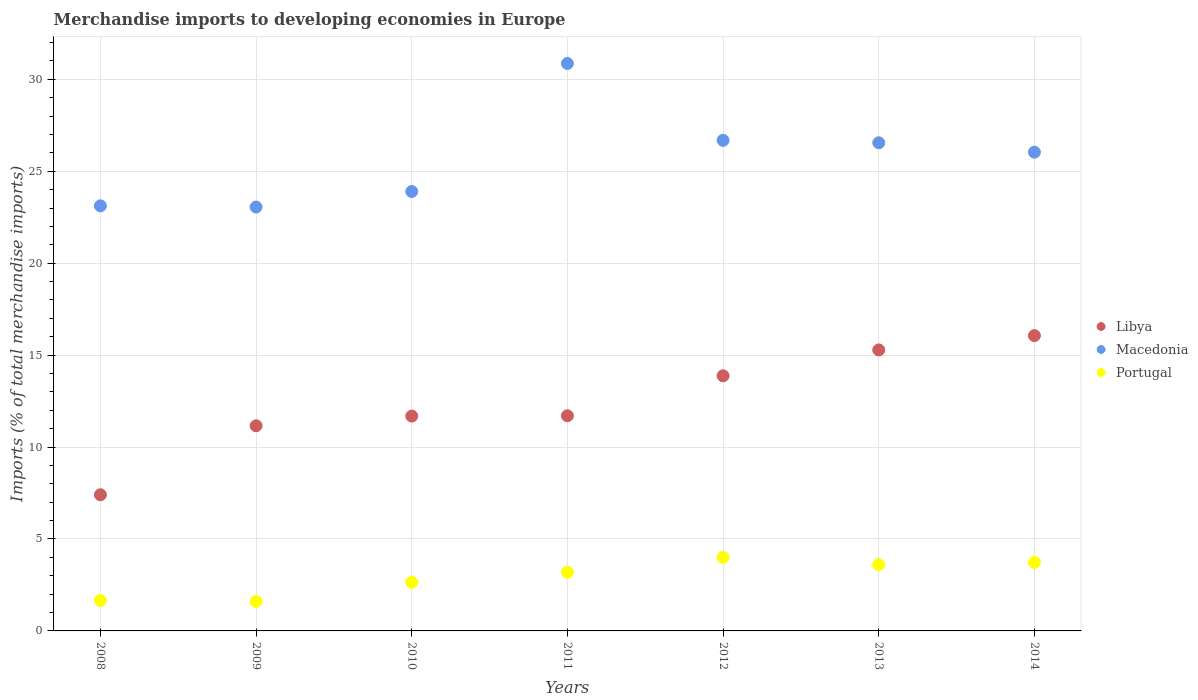How many different coloured dotlines are there?
Your answer should be compact. 3. What is the percentage total merchandise imports in Macedonia in 2010?
Give a very brief answer. 23.9. Across all years, what is the maximum percentage total merchandise imports in Portugal?
Your answer should be compact. 4. Across all years, what is the minimum percentage total merchandise imports in Libya?
Keep it short and to the point. 7.41. In which year was the percentage total merchandise imports in Portugal maximum?
Make the answer very short. 2012. In which year was the percentage total merchandise imports in Macedonia minimum?
Provide a succinct answer. 2009. What is the total percentage total merchandise imports in Libya in the graph?
Offer a terse response. 87.17. What is the difference between the percentage total merchandise imports in Libya in 2012 and that in 2013?
Keep it short and to the point. -1.41. What is the difference between the percentage total merchandise imports in Portugal in 2014 and the percentage total merchandise imports in Libya in 2009?
Make the answer very short. -7.43. What is the average percentage total merchandise imports in Libya per year?
Your answer should be compact. 12.45. In the year 2011, what is the difference between the percentage total merchandise imports in Libya and percentage total merchandise imports in Macedonia?
Provide a succinct answer. -19.16. In how many years, is the percentage total merchandise imports in Macedonia greater than 6 %?
Ensure brevity in your answer.  7. What is the ratio of the percentage total merchandise imports in Portugal in 2008 to that in 2014?
Your answer should be compact. 0.44. Is the percentage total merchandise imports in Macedonia in 2008 less than that in 2012?
Keep it short and to the point. Yes. What is the difference between the highest and the second highest percentage total merchandise imports in Libya?
Offer a very short reply. 0.78. What is the difference between the highest and the lowest percentage total merchandise imports in Macedonia?
Your response must be concise. 7.81. Is the percentage total merchandise imports in Libya strictly greater than the percentage total merchandise imports in Portugal over the years?
Give a very brief answer. Yes. Is the percentage total merchandise imports in Macedonia strictly less than the percentage total merchandise imports in Libya over the years?
Give a very brief answer. No. What is the difference between two consecutive major ticks on the Y-axis?
Keep it short and to the point. 5. Are the values on the major ticks of Y-axis written in scientific E-notation?
Provide a short and direct response. No. Does the graph contain any zero values?
Your answer should be compact. No. How many legend labels are there?
Your answer should be very brief. 3. How are the legend labels stacked?
Your answer should be compact. Vertical. What is the title of the graph?
Your answer should be very brief. Merchandise imports to developing economies in Europe. What is the label or title of the Y-axis?
Keep it short and to the point. Imports (% of total merchandise imports). What is the Imports (% of total merchandise imports) of Libya in 2008?
Offer a terse response. 7.41. What is the Imports (% of total merchandise imports) in Macedonia in 2008?
Give a very brief answer. 23.12. What is the Imports (% of total merchandise imports) of Portugal in 2008?
Your response must be concise. 1.66. What is the Imports (% of total merchandise imports) in Libya in 2009?
Offer a terse response. 11.16. What is the Imports (% of total merchandise imports) in Macedonia in 2009?
Your answer should be very brief. 23.06. What is the Imports (% of total merchandise imports) in Portugal in 2009?
Your response must be concise. 1.6. What is the Imports (% of total merchandise imports) of Libya in 2010?
Give a very brief answer. 11.69. What is the Imports (% of total merchandise imports) of Macedonia in 2010?
Keep it short and to the point. 23.9. What is the Imports (% of total merchandise imports) in Portugal in 2010?
Give a very brief answer. 2.65. What is the Imports (% of total merchandise imports) of Libya in 2011?
Make the answer very short. 11.7. What is the Imports (% of total merchandise imports) of Macedonia in 2011?
Provide a succinct answer. 30.87. What is the Imports (% of total merchandise imports) in Portugal in 2011?
Your response must be concise. 3.19. What is the Imports (% of total merchandise imports) of Libya in 2012?
Give a very brief answer. 13.88. What is the Imports (% of total merchandise imports) of Macedonia in 2012?
Offer a very short reply. 26.68. What is the Imports (% of total merchandise imports) in Portugal in 2012?
Provide a short and direct response. 4. What is the Imports (% of total merchandise imports) of Libya in 2013?
Your answer should be very brief. 15.28. What is the Imports (% of total merchandise imports) in Macedonia in 2013?
Your answer should be compact. 26.55. What is the Imports (% of total merchandise imports) of Portugal in 2013?
Provide a short and direct response. 3.6. What is the Imports (% of total merchandise imports) of Libya in 2014?
Offer a terse response. 16.06. What is the Imports (% of total merchandise imports) in Macedonia in 2014?
Keep it short and to the point. 26.04. What is the Imports (% of total merchandise imports) of Portugal in 2014?
Your answer should be compact. 3.73. Across all years, what is the maximum Imports (% of total merchandise imports) of Libya?
Your response must be concise. 16.06. Across all years, what is the maximum Imports (% of total merchandise imports) in Macedonia?
Keep it short and to the point. 30.87. Across all years, what is the maximum Imports (% of total merchandise imports) of Portugal?
Offer a terse response. 4. Across all years, what is the minimum Imports (% of total merchandise imports) in Libya?
Your answer should be very brief. 7.41. Across all years, what is the minimum Imports (% of total merchandise imports) of Macedonia?
Your response must be concise. 23.06. Across all years, what is the minimum Imports (% of total merchandise imports) of Portugal?
Ensure brevity in your answer.  1.6. What is the total Imports (% of total merchandise imports) in Libya in the graph?
Make the answer very short. 87.17. What is the total Imports (% of total merchandise imports) of Macedonia in the graph?
Give a very brief answer. 180.22. What is the total Imports (% of total merchandise imports) of Portugal in the graph?
Keep it short and to the point. 20.43. What is the difference between the Imports (% of total merchandise imports) in Libya in 2008 and that in 2009?
Provide a succinct answer. -3.75. What is the difference between the Imports (% of total merchandise imports) of Macedonia in 2008 and that in 2009?
Ensure brevity in your answer.  0.07. What is the difference between the Imports (% of total merchandise imports) in Portugal in 2008 and that in 2009?
Ensure brevity in your answer.  0.05. What is the difference between the Imports (% of total merchandise imports) in Libya in 2008 and that in 2010?
Provide a succinct answer. -4.28. What is the difference between the Imports (% of total merchandise imports) of Macedonia in 2008 and that in 2010?
Give a very brief answer. -0.78. What is the difference between the Imports (% of total merchandise imports) in Portugal in 2008 and that in 2010?
Keep it short and to the point. -0.99. What is the difference between the Imports (% of total merchandise imports) of Libya in 2008 and that in 2011?
Your answer should be very brief. -4.3. What is the difference between the Imports (% of total merchandise imports) of Macedonia in 2008 and that in 2011?
Your answer should be compact. -7.74. What is the difference between the Imports (% of total merchandise imports) of Portugal in 2008 and that in 2011?
Provide a succinct answer. -1.53. What is the difference between the Imports (% of total merchandise imports) of Libya in 2008 and that in 2012?
Ensure brevity in your answer.  -6.47. What is the difference between the Imports (% of total merchandise imports) of Macedonia in 2008 and that in 2012?
Ensure brevity in your answer.  -3.56. What is the difference between the Imports (% of total merchandise imports) in Portugal in 2008 and that in 2012?
Your answer should be very brief. -2.35. What is the difference between the Imports (% of total merchandise imports) in Libya in 2008 and that in 2013?
Make the answer very short. -7.88. What is the difference between the Imports (% of total merchandise imports) of Macedonia in 2008 and that in 2013?
Provide a short and direct response. -3.43. What is the difference between the Imports (% of total merchandise imports) of Portugal in 2008 and that in 2013?
Ensure brevity in your answer.  -1.95. What is the difference between the Imports (% of total merchandise imports) of Libya in 2008 and that in 2014?
Provide a short and direct response. -8.66. What is the difference between the Imports (% of total merchandise imports) of Macedonia in 2008 and that in 2014?
Make the answer very short. -2.92. What is the difference between the Imports (% of total merchandise imports) in Portugal in 2008 and that in 2014?
Provide a succinct answer. -2.07. What is the difference between the Imports (% of total merchandise imports) of Libya in 2009 and that in 2010?
Offer a terse response. -0.53. What is the difference between the Imports (% of total merchandise imports) in Macedonia in 2009 and that in 2010?
Make the answer very short. -0.85. What is the difference between the Imports (% of total merchandise imports) in Portugal in 2009 and that in 2010?
Your answer should be compact. -1.04. What is the difference between the Imports (% of total merchandise imports) of Libya in 2009 and that in 2011?
Ensure brevity in your answer.  -0.55. What is the difference between the Imports (% of total merchandise imports) in Macedonia in 2009 and that in 2011?
Make the answer very short. -7.81. What is the difference between the Imports (% of total merchandise imports) of Portugal in 2009 and that in 2011?
Your answer should be very brief. -1.59. What is the difference between the Imports (% of total merchandise imports) of Libya in 2009 and that in 2012?
Provide a succinct answer. -2.72. What is the difference between the Imports (% of total merchandise imports) of Macedonia in 2009 and that in 2012?
Your answer should be very brief. -3.63. What is the difference between the Imports (% of total merchandise imports) in Portugal in 2009 and that in 2012?
Offer a very short reply. -2.4. What is the difference between the Imports (% of total merchandise imports) of Libya in 2009 and that in 2013?
Offer a terse response. -4.13. What is the difference between the Imports (% of total merchandise imports) of Macedonia in 2009 and that in 2013?
Keep it short and to the point. -3.5. What is the difference between the Imports (% of total merchandise imports) in Libya in 2009 and that in 2014?
Your response must be concise. -4.91. What is the difference between the Imports (% of total merchandise imports) in Macedonia in 2009 and that in 2014?
Make the answer very short. -2.99. What is the difference between the Imports (% of total merchandise imports) in Portugal in 2009 and that in 2014?
Provide a short and direct response. -2.12. What is the difference between the Imports (% of total merchandise imports) of Libya in 2010 and that in 2011?
Make the answer very short. -0.02. What is the difference between the Imports (% of total merchandise imports) of Macedonia in 2010 and that in 2011?
Ensure brevity in your answer.  -6.96. What is the difference between the Imports (% of total merchandise imports) in Portugal in 2010 and that in 2011?
Keep it short and to the point. -0.54. What is the difference between the Imports (% of total merchandise imports) in Libya in 2010 and that in 2012?
Give a very brief answer. -2.19. What is the difference between the Imports (% of total merchandise imports) in Macedonia in 2010 and that in 2012?
Your response must be concise. -2.78. What is the difference between the Imports (% of total merchandise imports) of Portugal in 2010 and that in 2012?
Make the answer very short. -1.36. What is the difference between the Imports (% of total merchandise imports) of Libya in 2010 and that in 2013?
Your answer should be very brief. -3.6. What is the difference between the Imports (% of total merchandise imports) in Macedonia in 2010 and that in 2013?
Make the answer very short. -2.65. What is the difference between the Imports (% of total merchandise imports) in Portugal in 2010 and that in 2013?
Offer a terse response. -0.96. What is the difference between the Imports (% of total merchandise imports) in Libya in 2010 and that in 2014?
Ensure brevity in your answer.  -4.38. What is the difference between the Imports (% of total merchandise imports) in Macedonia in 2010 and that in 2014?
Offer a very short reply. -2.14. What is the difference between the Imports (% of total merchandise imports) of Portugal in 2010 and that in 2014?
Offer a very short reply. -1.08. What is the difference between the Imports (% of total merchandise imports) in Libya in 2011 and that in 2012?
Provide a succinct answer. -2.17. What is the difference between the Imports (% of total merchandise imports) of Macedonia in 2011 and that in 2012?
Offer a terse response. 4.18. What is the difference between the Imports (% of total merchandise imports) of Portugal in 2011 and that in 2012?
Ensure brevity in your answer.  -0.81. What is the difference between the Imports (% of total merchandise imports) of Libya in 2011 and that in 2013?
Offer a very short reply. -3.58. What is the difference between the Imports (% of total merchandise imports) of Macedonia in 2011 and that in 2013?
Offer a very short reply. 4.31. What is the difference between the Imports (% of total merchandise imports) in Portugal in 2011 and that in 2013?
Make the answer very short. -0.41. What is the difference between the Imports (% of total merchandise imports) in Libya in 2011 and that in 2014?
Offer a very short reply. -4.36. What is the difference between the Imports (% of total merchandise imports) in Macedonia in 2011 and that in 2014?
Ensure brevity in your answer.  4.82. What is the difference between the Imports (% of total merchandise imports) in Portugal in 2011 and that in 2014?
Provide a succinct answer. -0.54. What is the difference between the Imports (% of total merchandise imports) of Libya in 2012 and that in 2013?
Make the answer very short. -1.41. What is the difference between the Imports (% of total merchandise imports) of Macedonia in 2012 and that in 2013?
Your answer should be compact. 0.13. What is the difference between the Imports (% of total merchandise imports) in Portugal in 2012 and that in 2013?
Make the answer very short. 0.4. What is the difference between the Imports (% of total merchandise imports) of Libya in 2012 and that in 2014?
Provide a short and direct response. -2.19. What is the difference between the Imports (% of total merchandise imports) of Macedonia in 2012 and that in 2014?
Make the answer very short. 0.64. What is the difference between the Imports (% of total merchandise imports) in Portugal in 2012 and that in 2014?
Provide a succinct answer. 0.28. What is the difference between the Imports (% of total merchandise imports) of Libya in 2013 and that in 2014?
Offer a very short reply. -0.78. What is the difference between the Imports (% of total merchandise imports) of Macedonia in 2013 and that in 2014?
Provide a succinct answer. 0.51. What is the difference between the Imports (% of total merchandise imports) of Portugal in 2013 and that in 2014?
Your answer should be very brief. -0.12. What is the difference between the Imports (% of total merchandise imports) of Libya in 2008 and the Imports (% of total merchandise imports) of Macedonia in 2009?
Your response must be concise. -15.65. What is the difference between the Imports (% of total merchandise imports) in Libya in 2008 and the Imports (% of total merchandise imports) in Portugal in 2009?
Give a very brief answer. 5.8. What is the difference between the Imports (% of total merchandise imports) of Macedonia in 2008 and the Imports (% of total merchandise imports) of Portugal in 2009?
Keep it short and to the point. 21.52. What is the difference between the Imports (% of total merchandise imports) of Libya in 2008 and the Imports (% of total merchandise imports) of Macedonia in 2010?
Make the answer very short. -16.5. What is the difference between the Imports (% of total merchandise imports) in Libya in 2008 and the Imports (% of total merchandise imports) in Portugal in 2010?
Your answer should be very brief. 4.76. What is the difference between the Imports (% of total merchandise imports) in Macedonia in 2008 and the Imports (% of total merchandise imports) in Portugal in 2010?
Keep it short and to the point. 20.47. What is the difference between the Imports (% of total merchandise imports) of Libya in 2008 and the Imports (% of total merchandise imports) of Macedonia in 2011?
Give a very brief answer. -23.46. What is the difference between the Imports (% of total merchandise imports) in Libya in 2008 and the Imports (% of total merchandise imports) in Portugal in 2011?
Make the answer very short. 4.22. What is the difference between the Imports (% of total merchandise imports) in Macedonia in 2008 and the Imports (% of total merchandise imports) in Portugal in 2011?
Keep it short and to the point. 19.93. What is the difference between the Imports (% of total merchandise imports) in Libya in 2008 and the Imports (% of total merchandise imports) in Macedonia in 2012?
Make the answer very short. -19.28. What is the difference between the Imports (% of total merchandise imports) of Libya in 2008 and the Imports (% of total merchandise imports) of Portugal in 2012?
Make the answer very short. 3.4. What is the difference between the Imports (% of total merchandise imports) in Macedonia in 2008 and the Imports (% of total merchandise imports) in Portugal in 2012?
Offer a terse response. 19.12. What is the difference between the Imports (% of total merchandise imports) of Libya in 2008 and the Imports (% of total merchandise imports) of Macedonia in 2013?
Provide a succinct answer. -19.15. What is the difference between the Imports (% of total merchandise imports) in Libya in 2008 and the Imports (% of total merchandise imports) in Portugal in 2013?
Offer a terse response. 3.8. What is the difference between the Imports (% of total merchandise imports) of Macedonia in 2008 and the Imports (% of total merchandise imports) of Portugal in 2013?
Offer a very short reply. 19.52. What is the difference between the Imports (% of total merchandise imports) of Libya in 2008 and the Imports (% of total merchandise imports) of Macedonia in 2014?
Your answer should be compact. -18.64. What is the difference between the Imports (% of total merchandise imports) of Libya in 2008 and the Imports (% of total merchandise imports) of Portugal in 2014?
Offer a very short reply. 3.68. What is the difference between the Imports (% of total merchandise imports) of Macedonia in 2008 and the Imports (% of total merchandise imports) of Portugal in 2014?
Ensure brevity in your answer.  19.4. What is the difference between the Imports (% of total merchandise imports) of Libya in 2009 and the Imports (% of total merchandise imports) of Macedonia in 2010?
Keep it short and to the point. -12.75. What is the difference between the Imports (% of total merchandise imports) in Libya in 2009 and the Imports (% of total merchandise imports) in Portugal in 2010?
Your response must be concise. 8.51. What is the difference between the Imports (% of total merchandise imports) of Macedonia in 2009 and the Imports (% of total merchandise imports) of Portugal in 2010?
Provide a succinct answer. 20.41. What is the difference between the Imports (% of total merchandise imports) in Libya in 2009 and the Imports (% of total merchandise imports) in Macedonia in 2011?
Ensure brevity in your answer.  -19.71. What is the difference between the Imports (% of total merchandise imports) in Libya in 2009 and the Imports (% of total merchandise imports) in Portugal in 2011?
Offer a very short reply. 7.97. What is the difference between the Imports (% of total merchandise imports) in Macedonia in 2009 and the Imports (% of total merchandise imports) in Portugal in 2011?
Ensure brevity in your answer.  19.87. What is the difference between the Imports (% of total merchandise imports) of Libya in 2009 and the Imports (% of total merchandise imports) of Macedonia in 2012?
Offer a very short reply. -15.53. What is the difference between the Imports (% of total merchandise imports) of Libya in 2009 and the Imports (% of total merchandise imports) of Portugal in 2012?
Your answer should be compact. 7.15. What is the difference between the Imports (% of total merchandise imports) in Macedonia in 2009 and the Imports (% of total merchandise imports) in Portugal in 2012?
Provide a short and direct response. 19.05. What is the difference between the Imports (% of total merchandise imports) of Libya in 2009 and the Imports (% of total merchandise imports) of Macedonia in 2013?
Offer a terse response. -15.4. What is the difference between the Imports (% of total merchandise imports) of Libya in 2009 and the Imports (% of total merchandise imports) of Portugal in 2013?
Offer a very short reply. 7.55. What is the difference between the Imports (% of total merchandise imports) in Macedonia in 2009 and the Imports (% of total merchandise imports) in Portugal in 2013?
Make the answer very short. 19.45. What is the difference between the Imports (% of total merchandise imports) of Libya in 2009 and the Imports (% of total merchandise imports) of Macedonia in 2014?
Your answer should be very brief. -14.88. What is the difference between the Imports (% of total merchandise imports) in Libya in 2009 and the Imports (% of total merchandise imports) in Portugal in 2014?
Offer a very short reply. 7.43. What is the difference between the Imports (% of total merchandise imports) of Macedonia in 2009 and the Imports (% of total merchandise imports) of Portugal in 2014?
Provide a succinct answer. 19.33. What is the difference between the Imports (% of total merchandise imports) in Libya in 2010 and the Imports (% of total merchandise imports) in Macedonia in 2011?
Your answer should be very brief. -19.18. What is the difference between the Imports (% of total merchandise imports) of Libya in 2010 and the Imports (% of total merchandise imports) of Portugal in 2011?
Your response must be concise. 8.5. What is the difference between the Imports (% of total merchandise imports) of Macedonia in 2010 and the Imports (% of total merchandise imports) of Portugal in 2011?
Your answer should be very brief. 20.71. What is the difference between the Imports (% of total merchandise imports) of Libya in 2010 and the Imports (% of total merchandise imports) of Macedonia in 2012?
Give a very brief answer. -15. What is the difference between the Imports (% of total merchandise imports) of Libya in 2010 and the Imports (% of total merchandise imports) of Portugal in 2012?
Ensure brevity in your answer.  7.68. What is the difference between the Imports (% of total merchandise imports) of Macedonia in 2010 and the Imports (% of total merchandise imports) of Portugal in 2012?
Your answer should be very brief. 19.9. What is the difference between the Imports (% of total merchandise imports) in Libya in 2010 and the Imports (% of total merchandise imports) in Macedonia in 2013?
Provide a short and direct response. -14.87. What is the difference between the Imports (% of total merchandise imports) of Libya in 2010 and the Imports (% of total merchandise imports) of Portugal in 2013?
Keep it short and to the point. 8.08. What is the difference between the Imports (% of total merchandise imports) of Macedonia in 2010 and the Imports (% of total merchandise imports) of Portugal in 2013?
Keep it short and to the point. 20.3. What is the difference between the Imports (% of total merchandise imports) of Libya in 2010 and the Imports (% of total merchandise imports) of Macedonia in 2014?
Provide a short and direct response. -14.36. What is the difference between the Imports (% of total merchandise imports) of Libya in 2010 and the Imports (% of total merchandise imports) of Portugal in 2014?
Provide a succinct answer. 7.96. What is the difference between the Imports (% of total merchandise imports) of Macedonia in 2010 and the Imports (% of total merchandise imports) of Portugal in 2014?
Ensure brevity in your answer.  20.18. What is the difference between the Imports (% of total merchandise imports) of Libya in 2011 and the Imports (% of total merchandise imports) of Macedonia in 2012?
Your answer should be very brief. -14.98. What is the difference between the Imports (% of total merchandise imports) in Libya in 2011 and the Imports (% of total merchandise imports) in Portugal in 2012?
Your answer should be compact. 7.7. What is the difference between the Imports (% of total merchandise imports) in Macedonia in 2011 and the Imports (% of total merchandise imports) in Portugal in 2012?
Give a very brief answer. 26.86. What is the difference between the Imports (% of total merchandise imports) of Libya in 2011 and the Imports (% of total merchandise imports) of Macedonia in 2013?
Give a very brief answer. -14.85. What is the difference between the Imports (% of total merchandise imports) of Libya in 2011 and the Imports (% of total merchandise imports) of Portugal in 2013?
Provide a short and direct response. 8.1. What is the difference between the Imports (% of total merchandise imports) of Macedonia in 2011 and the Imports (% of total merchandise imports) of Portugal in 2013?
Ensure brevity in your answer.  27.26. What is the difference between the Imports (% of total merchandise imports) in Libya in 2011 and the Imports (% of total merchandise imports) in Macedonia in 2014?
Your answer should be very brief. -14.34. What is the difference between the Imports (% of total merchandise imports) of Libya in 2011 and the Imports (% of total merchandise imports) of Portugal in 2014?
Provide a succinct answer. 7.98. What is the difference between the Imports (% of total merchandise imports) in Macedonia in 2011 and the Imports (% of total merchandise imports) in Portugal in 2014?
Provide a short and direct response. 27.14. What is the difference between the Imports (% of total merchandise imports) in Libya in 2012 and the Imports (% of total merchandise imports) in Macedonia in 2013?
Offer a terse response. -12.68. What is the difference between the Imports (% of total merchandise imports) in Libya in 2012 and the Imports (% of total merchandise imports) in Portugal in 2013?
Make the answer very short. 10.27. What is the difference between the Imports (% of total merchandise imports) in Macedonia in 2012 and the Imports (% of total merchandise imports) in Portugal in 2013?
Give a very brief answer. 23.08. What is the difference between the Imports (% of total merchandise imports) of Libya in 2012 and the Imports (% of total merchandise imports) of Macedonia in 2014?
Ensure brevity in your answer.  -12.16. What is the difference between the Imports (% of total merchandise imports) in Libya in 2012 and the Imports (% of total merchandise imports) in Portugal in 2014?
Provide a succinct answer. 10.15. What is the difference between the Imports (% of total merchandise imports) of Macedonia in 2012 and the Imports (% of total merchandise imports) of Portugal in 2014?
Make the answer very short. 22.96. What is the difference between the Imports (% of total merchandise imports) of Libya in 2013 and the Imports (% of total merchandise imports) of Macedonia in 2014?
Your answer should be compact. -10.76. What is the difference between the Imports (% of total merchandise imports) of Libya in 2013 and the Imports (% of total merchandise imports) of Portugal in 2014?
Provide a short and direct response. 11.56. What is the difference between the Imports (% of total merchandise imports) of Macedonia in 2013 and the Imports (% of total merchandise imports) of Portugal in 2014?
Give a very brief answer. 22.83. What is the average Imports (% of total merchandise imports) of Libya per year?
Provide a succinct answer. 12.45. What is the average Imports (% of total merchandise imports) in Macedonia per year?
Give a very brief answer. 25.75. What is the average Imports (% of total merchandise imports) in Portugal per year?
Your answer should be very brief. 2.92. In the year 2008, what is the difference between the Imports (% of total merchandise imports) in Libya and Imports (% of total merchandise imports) in Macedonia?
Provide a short and direct response. -15.72. In the year 2008, what is the difference between the Imports (% of total merchandise imports) of Libya and Imports (% of total merchandise imports) of Portugal?
Your response must be concise. 5.75. In the year 2008, what is the difference between the Imports (% of total merchandise imports) of Macedonia and Imports (% of total merchandise imports) of Portugal?
Ensure brevity in your answer.  21.47. In the year 2009, what is the difference between the Imports (% of total merchandise imports) in Libya and Imports (% of total merchandise imports) in Macedonia?
Your response must be concise. -11.9. In the year 2009, what is the difference between the Imports (% of total merchandise imports) in Libya and Imports (% of total merchandise imports) in Portugal?
Keep it short and to the point. 9.55. In the year 2009, what is the difference between the Imports (% of total merchandise imports) in Macedonia and Imports (% of total merchandise imports) in Portugal?
Offer a very short reply. 21.45. In the year 2010, what is the difference between the Imports (% of total merchandise imports) in Libya and Imports (% of total merchandise imports) in Macedonia?
Offer a very short reply. -12.22. In the year 2010, what is the difference between the Imports (% of total merchandise imports) of Libya and Imports (% of total merchandise imports) of Portugal?
Provide a succinct answer. 9.04. In the year 2010, what is the difference between the Imports (% of total merchandise imports) in Macedonia and Imports (% of total merchandise imports) in Portugal?
Ensure brevity in your answer.  21.25. In the year 2011, what is the difference between the Imports (% of total merchandise imports) in Libya and Imports (% of total merchandise imports) in Macedonia?
Offer a very short reply. -19.16. In the year 2011, what is the difference between the Imports (% of total merchandise imports) of Libya and Imports (% of total merchandise imports) of Portugal?
Your response must be concise. 8.51. In the year 2011, what is the difference between the Imports (% of total merchandise imports) in Macedonia and Imports (% of total merchandise imports) in Portugal?
Give a very brief answer. 27.68. In the year 2012, what is the difference between the Imports (% of total merchandise imports) of Libya and Imports (% of total merchandise imports) of Macedonia?
Offer a very short reply. -12.81. In the year 2012, what is the difference between the Imports (% of total merchandise imports) of Libya and Imports (% of total merchandise imports) of Portugal?
Your response must be concise. 9.87. In the year 2012, what is the difference between the Imports (% of total merchandise imports) in Macedonia and Imports (% of total merchandise imports) in Portugal?
Offer a very short reply. 22.68. In the year 2013, what is the difference between the Imports (% of total merchandise imports) of Libya and Imports (% of total merchandise imports) of Macedonia?
Your response must be concise. -11.27. In the year 2013, what is the difference between the Imports (% of total merchandise imports) in Libya and Imports (% of total merchandise imports) in Portugal?
Offer a terse response. 11.68. In the year 2013, what is the difference between the Imports (% of total merchandise imports) of Macedonia and Imports (% of total merchandise imports) of Portugal?
Your answer should be compact. 22.95. In the year 2014, what is the difference between the Imports (% of total merchandise imports) of Libya and Imports (% of total merchandise imports) of Macedonia?
Offer a terse response. -9.98. In the year 2014, what is the difference between the Imports (% of total merchandise imports) in Libya and Imports (% of total merchandise imports) in Portugal?
Offer a terse response. 12.34. In the year 2014, what is the difference between the Imports (% of total merchandise imports) in Macedonia and Imports (% of total merchandise imports) in Portugal?
Your response must be concise. 22.32. What is the ratio of the Imports (% of total merchandise imports) in Libya in 2008 to that in 2009?
Your response must be concise. 0.66. What is the ratio of the Imports (% of total merchandise imports) of Portugal in 2008 to that in 2009?
Make the answer very short. 1.03. What is the ratio of the Imports (% of total merchandise imports) of Libya in 2008 to that in 2010?
Give a very brief answer. 0.63. What is the ratio of the Imports (% of total merchandise imports) in Macedonia in 2008 to that in 2010?
Provide a succinct answer. 0.97. What is the ratio of the Imports (% of total merchandise imports) of Portugal in 2008 to that in 2010?
Give a very brief answer. 0.63. What is the ratio of the Imports (% of total merchandise imports) of Libya in 2008 to that in 2011?
Provide a short and direct response. 0.63. What is the ratio of the Imports (% of total merchandise imports) in Macedonia in 2008 to that in 2011?
Your answer should be very brief. 0.75. What is the ratio of the Imports (% of total merchandise imports) of Portugal in 2008 to that in 2011?
Your answer should be compact. 0.52. What is the ratio of the Imports (% of total merchandise imports) of Libya in 2008 to that in 2012?
Ensure brevity in your answer.  0.53. What is the ratio of the Imports (% of total merchandise imports) of Macedonia in 2008 to that in 2012?
Give a very brief answer. 0.87. What is the ratio of the Imports (% of total merchandise imports) of Portugal in 2008 to that in 2012?
Provide a succinct answer. 0.41. What is the ratio of the Imports (% of total merchandise imports) in Libya in 2008 to that in 2013?
Ensure brevity in your answer.  0.48. What is the ratio of the Imports (% of total merchandise imports) in Macedonia in 2008 to that in 2013?
Your response must be concise. 0.87. What is the ratio of the Imports (% of total merchandise imports) in Portugal in 2008 to that in 2013?
Offer a very short reply. 0.46. What is the ratio of the Imports (% of total merchandise imports) in Libya in 2008 to that in 2014?
Give a very brief answer. 0.46. What is the ratio of the Imports (% of total merchandise imports) of Macedonia in 2008 to that in 2014?
Keep it short and to the point. 0.89. What is the ratio of the Imports (% of total merchandise imports) of Portugal in 2008 to that in 2014?
Keep it short and to the point. 0.44. What is the ratio of the Imports (% of total merchandise imports) of Libya in 2009 to that in 2010?
Your response must be concise. 0.95. What is the ratio of the Imports (% of total merchandise imports) in Macedonia in 2009 to that in 2010?
Your response must be concise. 0.96. What is the ratio of the Imports (% of total merchandise imports) in Portugal in 2009 to that in 2010?
Keep it short and to the point. 0.61. What is the ratio of the Imports (% of total merchandise imports) in Libya in 2009 to that in 2011?
Your answer should be compact. 0.95. What is the ratio of the Imports (% of total merchandise imports) of Macedonia in 2009 to that in 2011?
Offer a very short reply. 0.75. What is the ratio of the Imports (% of total merchandise imports) in Portugal in 2009 to that in 2011?
Ensure brevity in your answer.  0.5. What is the ratio of the Imports (% of total merchandise imports) in Libya in 2009 to that in 2012?
Your response must be concise. 0.8. What is the ratio of the Imports (% of total merchandise imports) of Macedonia in 2009 to that in 2012?
Your answer should be compact. 0.86. What is the ratio of the Imports (% of total merchandise imports) in Portugal in 2009 to that in 2012?
Provide a short and direct response. 0.4. What is the ratio of the Imports (% of total merchandise imports) of Libya in 2009 to that in 2013?
Make the answer very short. 0.73. What is the ratio of the Imports (% of total merchandise imports) of Macedonia in 2009 to that in 2013?
Your answer should be very brief. 0.87. What is the ratio of the Imports (% of total merchandise imports) of Portugal in 2009 to that in 2013?
Offer a terse response. 0.44. What is the ratio of the Imports (% of total merchandise imports) of Libya in 2009 to that in 2014?
Keep it short and to the point. 0.69. What is the ratio of the Imports (% of total merchandise imports) in Macedonia in 2009 to that in 2014?
Your answer should be compact. 0.89. What is the ratio of the Imports (% of total merchandise imports) in Portugal in 2009 to that in 2014?
Give a very brief answer. 0.43. What is the ratio of the Imports (% of total merchandise imports) of Macedonia in 2010 to that in 2011?
Give a very brief answer. 0.77. What is the ratio of the Imports (% of total merchandise imports) in Portugal in 2010 to that in 2011?
Provide a short and direct response. 0.83. What is the ratio of the Imports (% of total merchandise imports) in Libya in 2010 to that in 2012?
Your answer should be very brief. 0.84. What is the ratio of the Imports (% of total merchandise imports) of Macedonia in 2010 to that in 2012?
Keep it short and to the point. 0.9. What is the ratio of the Imports (% of total merchandise imports) of Portugal in 2010 to that in 2012?
Your answer should be compact. 0.66. What is the ratio of the Imports (% of total merchandise imports) of Libya in 2010 to that in 2013?
Offer a terse response. 0.76. What is the ratio of the Imports (% of total merchandise imports) in Macedonia in 2010 to that in 2013?
Ensure brevity in your answer.  0.9. What is the ratio of the Imports (% of total merchandise imports) of Portugal in 2010 to that in 2013?
Your answer should be very brief. 0.73. What is the ratio of the Imports (% of total merchandise imports) in Libya in 2010 to that in 2014?
Provide a short and direct response. 0.73. What is the ratio of the Imports (% of total merchandise imports) of Macedonia in 2010 to that in 2014?
Your answer should be compact. 0.92. What is the ratio of the Imports (% of total merchandise imports) of Portugal in 2010 to that in 2014?
Ensure brevity in your answer.  0.71. What is the ratio of the Imports (% of total merchandise imports) of Libya in 2011 to that in 2012?
Offer a terse response. 0.84. What is the ratio of the Imports (% of total merchandise imports) in Macedonia in 2011 to that in 2012?
Give a very brief answer. 1.16. What is the ratio of the Imports (% of total merchandise imports) in Portugal in 2011 to that in 2012?
Your response must be concise. 0.8. What is the ratio of the Imports (% of total merchandise imports) in Libya in 2011 to that in 2013?
Ensure brevity in your answer.  0.77. What is the ratio of the Imports (% of total merchandise imports) of Macedonia in 2011 to that in 2013?
Your answer should be very brief. 1.16. What is the ratio of the Imports (% of total merchandise imports) in Portugal in 2011 to that in 2013?
Keep it short and to the point. 0.89. What is the ratio of the Imports (% of total merchandise imports) in Libya in 2011 to that in 2014?
Offer a very short reply. 0.73. What is the ratio of the Imports (% of total merchandise imports) of Macedonia in 2011 to that in 2014?
Provide a succinct answer. 1.19. What is the ratio of the Imports (% of total merchandise imports) in Portugal in 2011 to that in 2014?
Offer a very short reply. 0.86. What is the ratio of the Imports (% of total merchandise imports) in Libya in 2012 to that in 2013?
Give a very brief answer. 0.91. What is the ratio of the Imports (% of total merchandise imports) in Macedonia in 2012 to that in 2013?
Provide a succinct answer. 1. What is the ratio of the Imports (% of total merchandise imports) of Portugal in 2012 to that in 2013?
Your answer should be very brief. 1.11. What is the ratio of the Imports (% of total merchandise imports) in Libya in 2012 to that in 2014?
Offer a terse response. 0.86. What is the ratio of the Imports (% of total merchandise imports) of Macedonia in 2012 to that in 2014?
Provide a short and direct response. 1.02. What is the ratio of the Imports (% of total merchandise imports) of Portugal in 2012 to that in 2014?
Make the answer very short. 1.07. What is the ratio of the Imports (% of total merchandise imports) of Libya in 2013 to that in 2014?
Offer a terse response. 0.95. What is the ratio of the Imports (% of total merchandise imports) of Macedonia in 2013 to that in 2014?
Give a very brief answer. 1.02. What is the ratio of the Imports (% of total merchandise imports) of Portugal in 2013 to that in 2014?
Provide a succinct answer. 0.97. What is the difference between the highest and the second highest Imports (% of total merchandise imports) of Libya?
Ensure brevity in your answer.  0.78. What is the difference between the highest and the second highest Imports (% of total merchandise imports) in Macedonia?
Your answer should be very brief. 4.18. What is the difference between the highest and the second highest Imports (% of total merchandise imports) of Portugal?
Ensure brevity in your answer.  0.28. What is the difference between the highest and the lowest Imports (% of total merchandise imports) in Libya?
Give a very brief answer. 8.66. What is the difference between the highest and the lowest Imports (% of total merchandise imports) of Macedonia?
Offer a terse response. 7.81. What is the difference between the highest and the lowest Imports (% of total merchandise imports) of Portugal?
Make the answer very short. 2.4. 